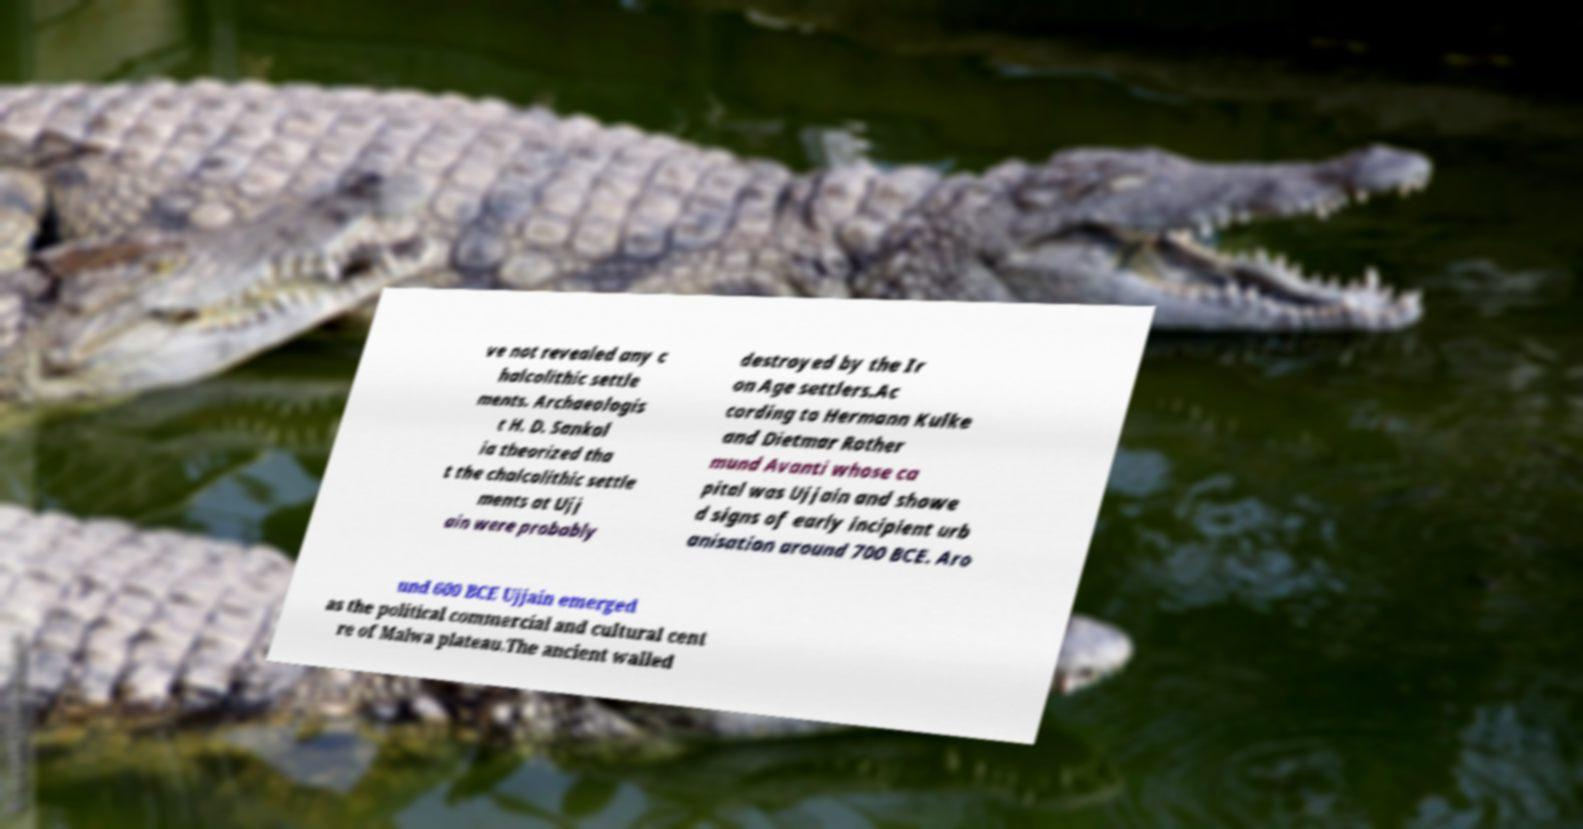For documentation purposes, I need the text within this image transcribed. Could you provide that? ve not revealed any c halcolithic settle ments. Archaeologis t H. D. Sankal ia theorized tha t the chalcolithic settle ments at Ujj ain were probably destroyed by the Ir on Age settlers.Ac cording to Hermann Kulke and Dietmar Rother mund Avanti whose ca pital was Ujjain and showe d signs of early incipient urb anisation around 700 BCE. Aro und 600 BCE Ujjain emerged as the political commercial and cultural cent re of Malwa plateau.The ancient walled 